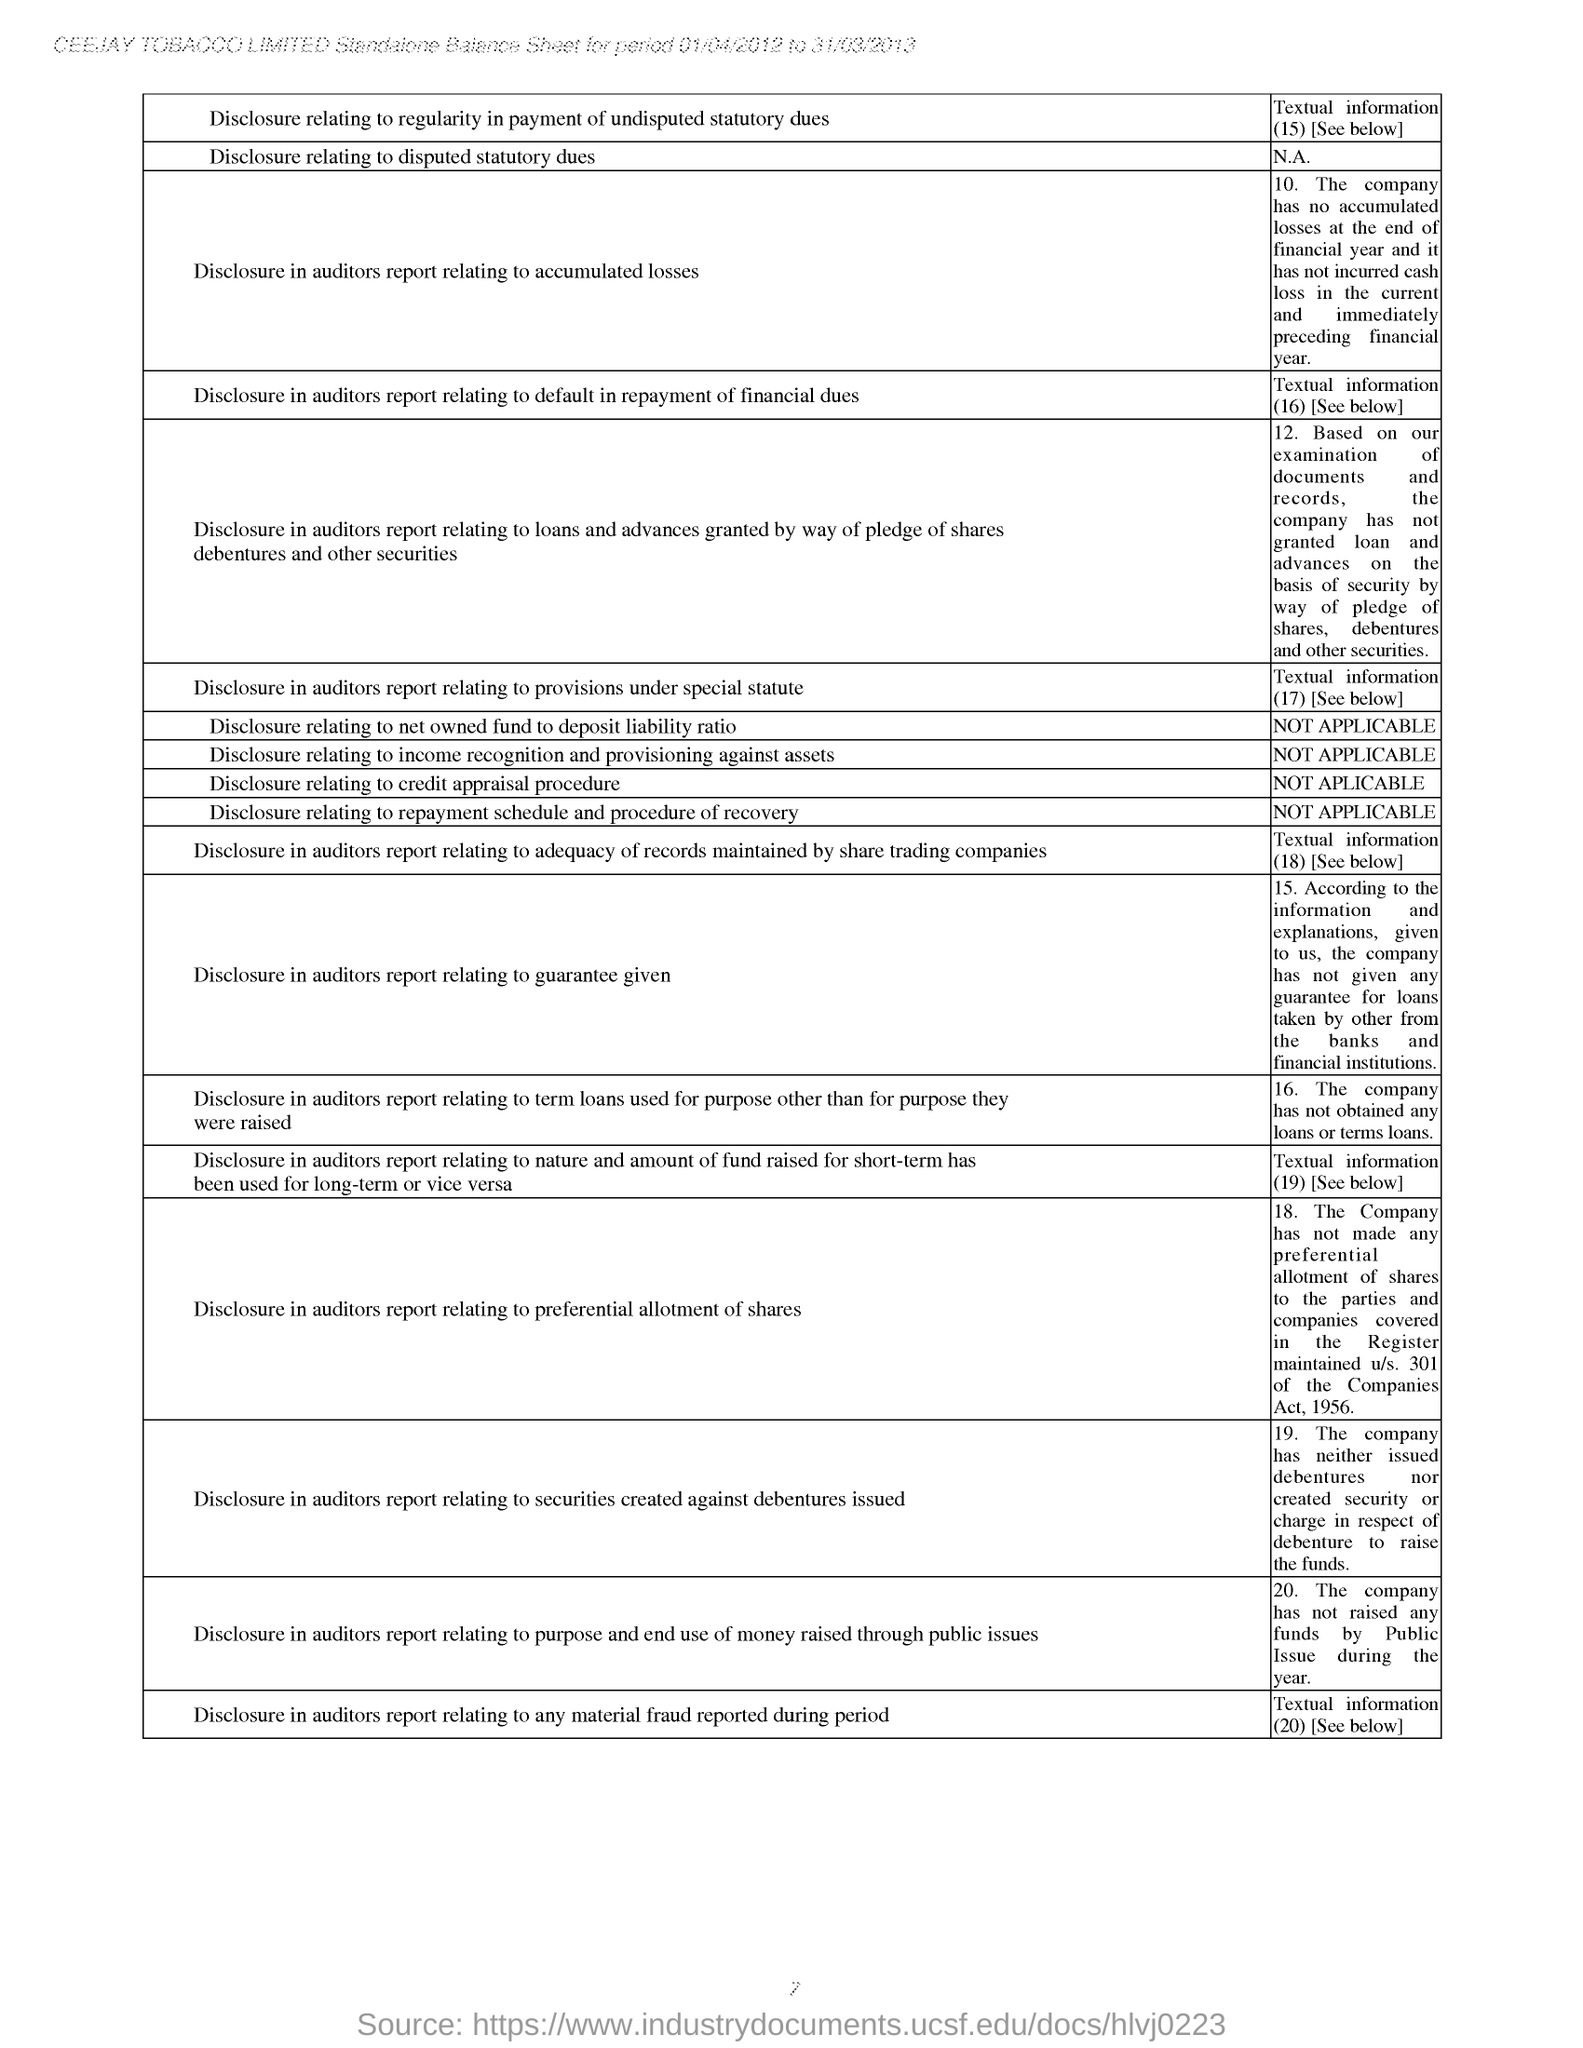What is the company name specified in the header of the document?
Your answer should be compact. CEEJAY TOBACCO LIMITED. What is the period of Standalone Balance Sheet according to the document header
Provide a succinct answer. 01/04/2012 to 31/03/2013. What is the Textual Information numbered '16.' based on the second column of the table?
Provide a succinct answer. The company has not obtained any loans or terms loans. 